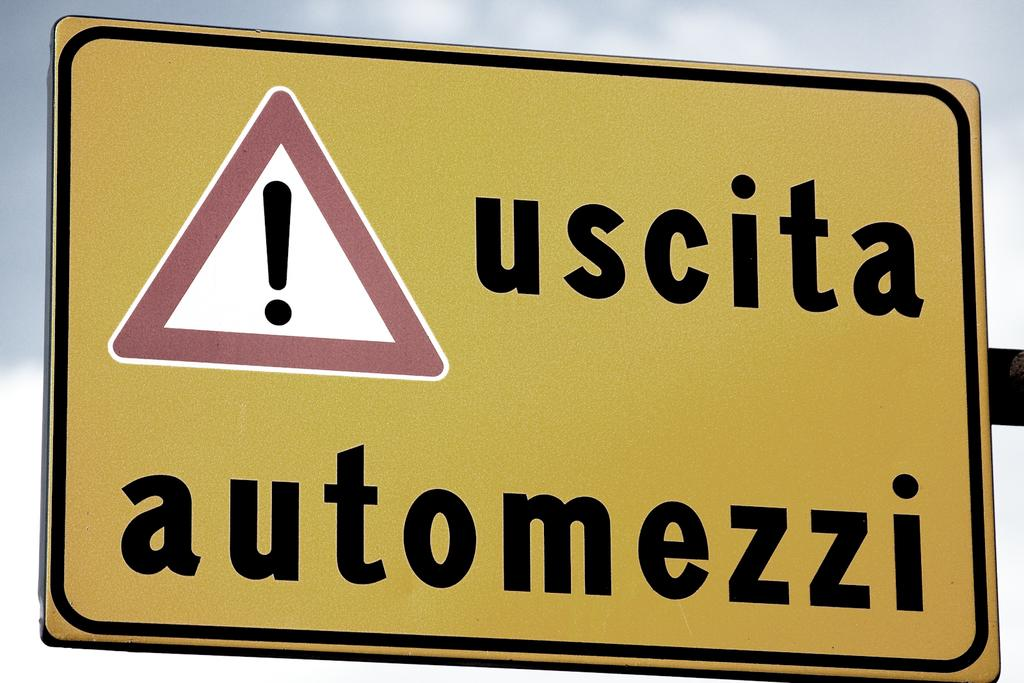<image>
Render a clear and concise summary of the photo. A traffic caution sign warning for uscita automezzi. 